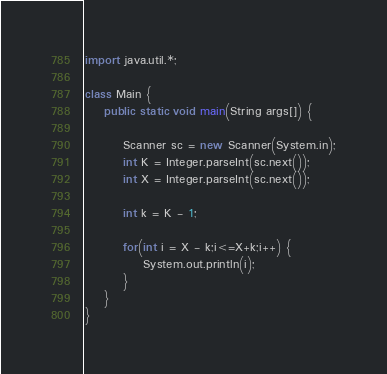Convert code to text. <code><loc_0><loc_0><loc_500><loc_500><_Java_>import java.util.*;

class Main {
	public static void main(String args[]) {
		
		Scanner sc = new Scanner(System.in);
		int K = Integer.parseInt(sc.next());
		int X = Integer.parseInt(sc.next());
		
      	int k = K - 1;
      
      	for(int i = X - k;i<=X+k;i++) {
			System.out.println(i);
        }
	}
}
</code> 